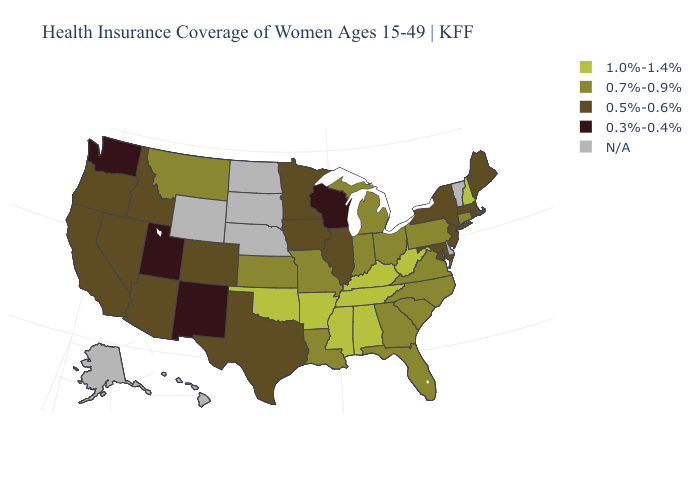Name the states that have a value in the range N/A?
Keep it brief. Alaska, Delaware, Hawaii, Nebraska, North Dakota, South Dakota, Vermont, Wyoming. What is the value of Florida?
Be succinct. 0.7%-0.9%. Does Maryland have the highest value in the South?
Give a very brief answer. No. What is the value of Iowa?
Keep it brief. 0.5%-0.6%. Does the map have missing data?
Keep it brief. Yes. Name the states that have a value in the range N/A?
Short answer required. Alaska, Delaware, Hawaii, Nebraska, North Dakota, South Dakota, Vermont, Wyoming. What is the highest value in the USA?
Short answer required. 1.0%-1.4%. Among the states that border Tennessee , which have the lowest value?
Concise answer only. Georgia, Missouri, North Carolina, Virginia. What is the value of Maryland?
Write a very short answer. 0.5%-0.6%. What is the highest value in states that border Rhode Island?
Give a very brief answer. 0.7%-0.9%. What is the value of Texas?
Keep it brief. 0.5%-0.6%. Among the states that border Louisiana , which have the highest value?
Keep it brief. Arkansas, Mississippi. Which states hav the highest value in the West?
Short answer required. Montana. Which states have the lowest value in the USA?
Quick response, please. New Mexico, Utah, Washington, Wisconsin. Does the map have missing data?
Give a very brief answer. Yes. 